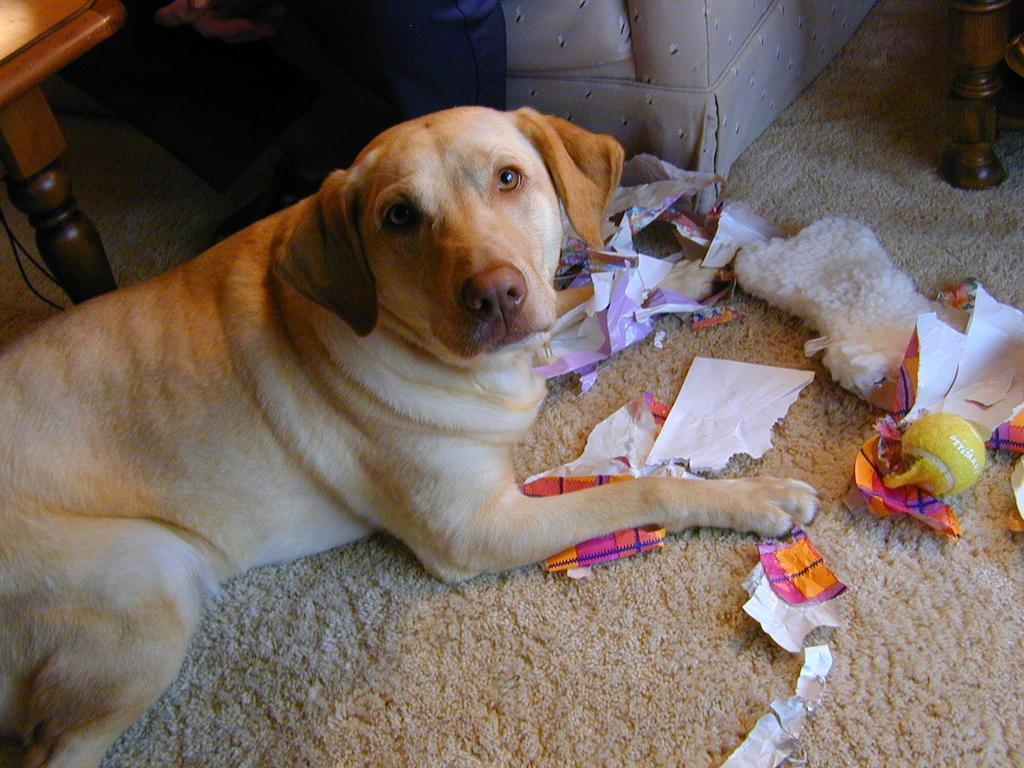Please provide a concise description of this image. In this image there is a dog sitting on the mat, in front of the dog there are papers and some other objects, behind the dog there is a couch and wooden tables. 